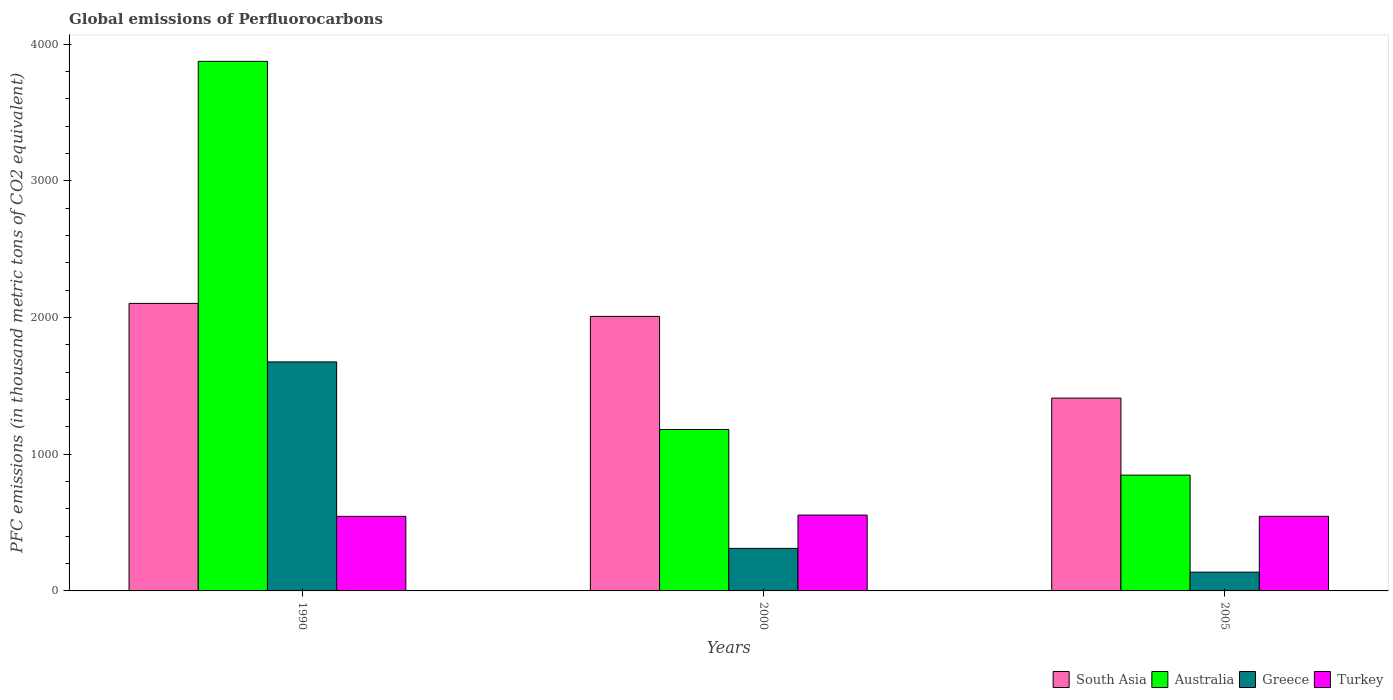What is the label of the 1st group of bars from the left?
Make the answer very short. 1990. In how many cases, is the number of bars for a given year not equal to the number of legend labels?
Your answer should be very brief. 0. What is the global emissions of Perfluorocarbons in Turkey in 2000?
Ensure brevity in your answer.  554.9. Across all years, what is the maximum global emissions of Perfluorocarbons in Greece?
Keep it short and to the point. 1675.9. Across all years, what is the minimum global emissions of Perfluorocarbons in Turkey?
Offer a very short reply. 545.6. In which year was the global emissions of Perfluorocarbons in Turkey minimum?
Give a very brief answer. 1990. What is the total global emissions of Perfluorocarbons in Greece in the graph?
Offer a terse response. 2124.7. What is the difference between the global emissions of Perfluorocarbons in Australia in 2000 and that in 2005?
Your response must be concise. 334. What is the difference between the global emissions of Perfluorocarbons in South Asia in 2000 and the global emissions of Perfluorocarbons in Turkey in 1990?
Give a very brief answer. 1463.2. What is the average global emissions of Perfluorocarbons in Turkey per year?
Your answer should be compact. 548.8. In the year 2005, what is the difference between the global emissions of Perfluorocarbons in South Asia and global emissions of Perfluorocarbons in Australia?
Make the answer very short. 563.44. In how many years, is the global emissions of Perfluorocarbons in Turkey greater than 1600 thousand metric tons?
Give a very brief answer. 0. What is the ratio of the global emissions of Perfluorocarbons in South Asia in 1990 to that in 2005?
Give a very brief answer. 1.49. What is the difference between the highest and the second highest global emissions of Perfluorocarbons in Australia?
Provide a short and direct response. 2693.8. What is the difference between the highest and the lowest global emissions of Perfluorocarbons in Greece?
Your answer should be very brief. 1538.4. Is it the case that in every year, the sum of the global emissions of Perfluorocarbons in Australia and global emissions of Perfluorocarbons in Turkey is greater than the sum of global emissions of Perfluorocarbons in South Asia and global emissions of Perfluorocarbons in Greece?
Offer a very short reply. No. Is it the case that in every year, the sum of the global emissions of Perfluorocarbons in Australia and global emissions of Perfluorocarbons in Greece is greater than the global emissions of Perfluorocarbons in South Asia?
Give a very brief answer. No. How many bars are there?
Keep it short and to the point. 12. Are all the bars in the graph horizontal?
Your answer should be compact. No. How many years are there in the graph?
Offer a very short reply. 3. What is the difference between two consecutive major ticks on the Y-axis?
Make the answer very short. 1000. Are the values on the major ticks of Y-axis written in scientific E-notation?
Provide a succinct answer. No. Does the graph contain any zero values?
Offer a terse response. No. Where does the legend appear in the graph?
Your answer should be very brief. Bottom right. How many legend labels are there?
Your answer should be compact. 4. How are the legend labels stacked?
Your answer should be compact. Horizontal. What is the title of the graph?
Provide a short and direct response. Global emissions of Perfluorocarbons. Does "Costa Rica" appear as one of the legend labels in the graph?
Provide a short and direct response. No. What is the label or title of the Y-axis?
Your response must be concise. PFC emissions (in thousand metric tons of CO2 equivalent). What is the PFC emissions (in thousand metric tons of CO2 equivalent) in South Asia in 1990?
Your response must be concise. 2104. What is the PFC emissions (in thousand metric tons of CO2 equivalent) in Australia in 1990?
Your answer should be compact. 3875.2. What is the PFC emissions (in thousand metric tons of CO2 equivalent) in Greece in 1990?
Your answer should be compact. 1675.9. What is the PFC emissions (in thousand metric tons of CO2 equivalent) of Turkey in 1990?
Offer a terse response. 545.6. What is the PFC emissions (in thousand metric tons of CO2 equivalent) in South Asia in 2000?
Make the answer very short. 2008.8. What is the PFC emissions (in thousand metric tons of CO2 equivalent) of Australia in 2000?
Keep it short and to the point. 1181.4. What is the PFC emissions (in thousand metric tons of CO2 equivalent) of Greece in 2000?
Your response must be concise. 311.3. What is the PFC emissions (in thousand metric tons of CO2 equivalent) in Turkey in 2000?
Give a very brief answer. 554.9. What is the PFC emissions (in thousand metric tons of CO2 equivalent) in South Asia in 2005?
Give a very brief answer. 1410.84. What is the PFC emissions (in thousand metric tons of CO2 equivalent) of Australia in 2005?
Your answer should be compact. 847.4. What is the PFC emissions (in thousand metric tons of CO2 equivalent) of Greece in 2005?
Offer a very short reply. 137.5. What is the PFC emissions (in thousand metric tons of CO2 equivalent) of Turkey in 2005?
Give a very brief answer. 545.9. Across all years, what is the maximum PFC emissions (in thousand metric tons of CO2 equivalent) of South Asia?
Offer a terse response. 2104. Across all years, what is the maximum PFC emissions (in thousand metric tons of CO2 equivalent) of Australia?
Provide a short and direct response. 3875.2. Across all years, what is the maximum PFC emissions (in thousand metric tons of CO2 equivalent) of Greece?
Provide a succinct answer. 1675.9. Across all years, what is the maximum PFC emissions (in thousand metric tons of CO2 equivalent) of Turkey?
Make the answer very short. 554.9. Across all years, what is the minimum PFC emissions (in thousand metric tons of CO2 equivalent) of South Asia?
Keep it short and to the point. 1410.84. Across all years, what is the minimum PFC emissions (in thousand metric tons of CO2 equivalent) in Australia?
Provide a short and direct response. 847.4. Across all years, what is the minimum PFC emissions (in thousand metric tons of CO2 equivalent) in Greece?
Your response must be concise. 137.5. Across all years, what is the minimum PFC emissions (in thousand metric tons of CO2 equivalent) in Turkey?
Make the answer very short. 545.6. What is the total PFC emissions (in thousand metric tons of CO2 equivalent) of South Asia in the graph?
Offer a terse response. 5523.64. What is the total PFC emissions (in thousand metric tons of CO2 equivalent) of Australia in the graph?
Give a very brief answer. 5904. What is the total PFC emissions (in thousand metric tons of CO2 equivalent) in Greece in the graph?
Your answer should be compact. 2124.7. What is the total PFC emissions (in thousand metric tons of CO2 equivalent) of Turkey in the graph?
Your answer should be compact. 1646.4. What is the difference between the PFC emissions (in thousand metric tons of CO2 equivalent) in South Asia in 1990 and that in 2000?
Offer a terse response. 95.2. What is the difference between the PFC emissions (in thousand metric tons of CO2 equivalent) in Australia in 1990 and that in 2000?
Your response must be concise. 2693.8. What is the difference between the PFC emissions (in thousand metric tons of CO2 equivalent) in Greece in 1990 and that in 2000?
Your answer should be very brief. 1364.6. What is the difference between the PFC emissions (in thousand metric tons of CO2 equivalent) in Turkey in 1990 and that in 2000?
Your answer should be compact. -9.3. What is the difference between the PFC emissions (in thousand metric tons of CO2 equivalent) of South Asia in 1990 and that in 2005?
Your response must be concise. 693.16. What is the difference between the PFC emissions (in thousand metric tons of CO2 equivalent) of Australia in 1990 and that in 2005?
Your answer should be very brief. 3027.8. What is the difference between the PFC emissions (in thousand metric tons of CO2 equivalent) in Greece in 1990 and that in 2005?
Provide a short and direct response. 1538.4. What is the difference between the PFC emissions (in thousand metric tons of CO2 equivalent) of South Asia in 2000 and that in 2005?
Provide a succinct answer. 597.96. What is the difference between the PFC emissions (in thousand metric tons of CO2 equivalent) of Australia in 2000 and that in 2005?
Provide a short and direct response. 334. What is the difference between the PFC emissions (in thousand metric tons of CO2 equivalent) of Greece in 2000 and that in 2005?
Ensure brevity in your answer.  173.8. What is the difference between the PFC emissions (in thousand metric tons of CO2 equivalent) in Turkey in 2000 and that in 2005?
Offer a terse response. 9. What is the difference between the PFC emissions (in thousand metric tons of CO2 equivalent) of South Asia in 1990 and the PFC emissions (in thousand metric tons of CO2 equivalent) of Australia in 2000?
Offer a very short reply. 922.6. What is the difference between the PFC emissions (in thousand metric tons of CO2 equivalent) of South Asia in 1990 and the PFC emissions (in thousand metric tons of CO2 equivalent) of Greece in 2000?
Your answer should be very brief. 1792.7. What is the difference between the PFC emissions (in thousand metric tons of CO2 equivalent) in South Asia in 1990 and the PFC emissions (in thousand metric tons of CO2 equivalent) in Turkey in 2000?
Ensure brevity in your answer.  1549.1. What is the difference between the PFC emissions (in thousand metric tons of CO2 equivalent) in Australia in 1990 and the PFC emissions (in thousand metric tons of CO2 equivalent) in Greece in 2000?
Your answer should be compact. 3563.9. What is the difference between the PFC emissions (in thousand metric tons of CO2 equivalent) in Australia in 1990 and the PFC emissions (in thousand metric tons of CO2 equivalent) in Turkey in 2000?
Offer a terse response. 3320.3. What is the difference between the PFC emissions (in thousand metric tons of CO2 equivalent) in Greece in 1990 and the PFC emissions (in thousand metric tons of CO2 equivalent) in Turkey in 2000?
Ensure brevity in your answer.  1121. What is the difference between the PFC emissions (in thousand metric tons of CO2 equivalent) of South Asia in 1990 and the PFC emissions (in thousand metric tons of CO2 equivalent) of Australia in 2005?
Your answer should be very brief. 1256.6. What is the difference between the PFC emissions (in thousand metric tons of CO2 equivalent) in South Asia in 1990 and the PFC emissions (in thousand metric tons of CO2 equivalent) in Greece in 2005?
Offer a terse response. 1966.5. What is the difference between the PFC emissions (in thousand metric tons of CO2 equivalent) of South Asia in 1990 and the PFC emissions (in thousand metric tons of CO2 equivalent) of Turkey in 2005?
Provide a short and direct response. 1558.1. What is the difference between the PFC emissions (in thousand metric tons of CO2 equivalent) of Australia in 1990 and the PFC emissions (in thousand metric tons of CO2 equivalent) of Greece in 2005?
Ensure brevity in your answer.  3737.7. What is the difference between the PFC emissions (in thousand metric tons of CO2 equivalent) of Australia in 1990 and the PFC emissions (in thousand metric tons of CO2 equivalent) of Turkey in 2005?
Offer a terse response. 3329.3. What is the difference between the PFC emissions (in thousand metric tons of CO2 equivalent) of Greece in 1990 and the PFC emissions (in thousand metric tons of CO2 equivalent) of Turkey in 2005?
Keep it short and to the point. 1130. What is the difference between the PFC emissions (in thousand metric tons of CO2 equivalent) of South Asia in 2000 and the PFC emissions (in thousand metric tons of CO2 equivalent) of Australia in 2005?
Offer a terse response. 1161.4. What is the difference between the PFC emissions (in thousand metric tons of CO2 equivalent) of South Asia in 2000 and the PFC emissions (in thousand metric tons of CO2 equivalent) of Greece in 2005?
Give a very brief answer. 1871.3. What is the difference between the PFC emissions (in thousand metric tons of CO2 equivalent) of South Asia in 2000 and the PFC emissions (in thousand metric tons of CO2 equivalent) of Turkey in 2005?
Offer a very short reply. 1462.9. What is the difference between the PFC emissions (in thousand metric tons of CO2 equivalent) of Australia in 2000 and the PFC emissions (in thousand metric tons of CO2 equivalent) of Greece in 2005?
Make the answer very short. 1043.9. What is the difference between the PFC emissions (in thousand metric tons of CO2 equivalent) in Australia in 2000 and the PFC emissions (in thousand metric tons of CO2 equivalent) in Turkey in 2005?
Provide a short and direct response. 635.5. What is the difference between the PFC emissions (in thousand metric tons of CO2 equivalent) of Greece in 2000 and the PFC emissions (in thousand metric tons of CO2 equivalent) of Turkey in 2005?
Provide a short and direct response. -234.6. What is the average PFC emissions (in thousand metric tons of CO2 equivalent) in South Asia per year?
Ensure brevity in your answer.  1841.21. What is the average PFC emissions (in thousand metric tons of CO2 equivalent) in Australia per year?
Give a very brief answer. 1968. What is the average PFC emissions (in thousand metric tons of CO2 equivalent) of Greece per year?
Offer a very short reply. 708.23. What is the average PFC emissions (in thousand metric tons of CO2 equivalent) in Turkey per year?
Offer a very short reply. 548.8. In the year 1990, what is the difference between the PFC emissions (in thousand metric tons of CO2 equivalent) in South Asia and PFC emissions (in thousand metric tons of CO2 equivalent) in Australia?
Provide a succinct answer. -1771.2. In the year 1990, what is the difference between the PFC emissions (in thousand metric tons of CO2 equivalent) in South Asia and PFC emissions (in thousand metric tons of CO2 equivalent) in Greece?
Make the answer very short. 428.1. In the year 1990, what is the difference between the PFC emissions (in thousand metric tons of CO2 equivalent) of South Asia and PFC emissions (in thousand metric tons of CO2 equivalent) of Turkey?
Your response must be concise. 1558.4. In the year 1990, what is the difference between the PFC emissions (in thousand metric tons of CO2 equivalent) in Australia and PFC emissions (in thousand metric tons of CO2 equivalent) in Greece?
Your response must be concise. 2199.3. In the year 1990, what is the difference between the PFC emissions (in thousand metric tons of CO2 equivalent) of Australia and PFC emissions (in thousand metric tons of CO2 equivalent) of Turkey?
Offer a terse response. 3329.6. In the year 1990, what is the difference between the PFC emissions (in thousand metric tons of CO2 equivalent) in Greece and PFC emissions (in thousand metric tons of CO2 equivalent) in Turkey?
Provide a succinct answer. 1130.3. In the year 2000, what is the difference between the PFC emissions (in thousand metric tons of CO2 equivalent) of South Asia and PFC emissions (in thousand metric tons of CO2 equivalent) of Australia?
Provide a succinct answer. 827.4. In the year 2000, what is the difference between the PFC emissions (in thousand metric tons of CO2 equivalent) in South Asia and PFC emissions (in thousand metric tons of CO2 equivalent) in Greece?
Your response must be concise. 1697.5. In the year 2000, what is the difference between the PFC emissions (in thousand metric tons of CO2 equivalent) of South Asia and PFC emissions (in thousand metric tons of CO2 equivalent) of Turkey?
Your answer should be compact. 1453.9. In the year 2000, what is the difference between the PFC emissions (in thousand metric tons of CO2 equivalent) of Australia and PFC emissions (in thousand metric tons of CO2 equivalent) of Greece?
Provide a short and direct response. 870.1. In the year 2000, what is the difference between the PFC emissions (in thousand metric tons of CO2 equivalent) in Australia and PFC emissions (in thousand metric tons of CO2 equivalent) in Turkey?
Your answer should be compact. 626.5. In the year 2000, what is the difference between the PFC emissions (in thousand metric tons of CO2 equivalent) in Greece and PFC emissions (in thousand metric tons of CO2 equivalent) in Turkey?
Keep it short and to the point. -243.6. In the year 2005, what is the difference between the PFC emissions (in thousand metric tons of CO2 equivalent) of South Asia and PFC emissions (in thousand metric tons of CO2 equivalent) of Australia?
Provide a succinct answer. 563.44. In the year 2005, what is the difference between the PFC emissions (in thousand metric tons of CO2 equivalent) of South Asia and PFC emissions (in thousand metric tons of CO2 equivalent) of Greece?
Ensure brevity in your answer.  1273.34. In the year 2005, what is the difference between the PFC emissions (in thousand metric tons of CO2 equivalent) in South Asia and PFC emissions (in thousand metric tons of CO2 equivalent) in Turkey?
Keep it short and to the point. 864.94. In the year 2005, what is the difference between the PFC emissions (in thousand metric tons of CO2 equivalent) in Australia and PFC emissions (in thousand metric tons of CO2 equivalent) in Greece?
Your response must be concise. 709.9. In the year 2005, what is the difference between the PFC emissions (in thousand metric tons of CO2 equivalent) in Australia and PFC emissions (in thousand metric tons of CO2 equivalent) in Turkey?
Ensure brevity in your answer.  301.5. In the year 2005, what is the difference between the PFC emissions (in thousand metric tons of CO2 equivalent) in Greece and PFC emissions (in thousand metric tons of CO2 equivalent) in Turkey?
Your response must be concise. -408.4. What is the ratio of the PFC emissions (in thousand metric tons of CO2 equivalent) in South Asia in 1990 to that in 2000?
Offer a very short reply. 1.05. What is the ratio of the PFC emissions (in thousand metric tons of CO2 equivalent) in Australia in 1990 to that in 2000?
Provide a succinct answer. 3.28. What is the ratio of the PFC emissions (in thousand metric tons of CO2 equivalent) of Greece in 1990 to that in 2000?
Provide a short and direct response. 5.38. What is the ratio of the PFC emissions (in thousand metric tons of CO2 equivalent) of Turkey in 1990 to that in 2000?
Your answer should be compact. 0.98. What is the ratio of the PFC emissions (in thousand metric tons of CO2 equivalent) in South Asia in 1990 to that in 2005?
Provide a short and direct response. 1.49. What is the ratio of the PFC emissions (in thousand metric tons of CO2 equivalent) in Australia in 1990 to that in 2005?
Make the answer very short. 4.57. What is the ratio of the PFC emissions (in thousand metric tons of CO2 equivalent) in Greece in 1990 to that in 2005?
Offer a very short reply. 12.19. What is the ratio of the PFC emissions (in thousand metric tons of CO2 equivalent) of South Asia in 2000 to that in 2005?
Your answer should be compact. 1.42. What is the ratio of the PFC emissions (in thousand metric tons of CO2 equivalent) of Australia in 2000 to that in 2005?
Keep it short and to the point. 1.39. What is the ratio of the PFC emissions (in thousand metric tons of CO2 equivalent) of Greece in 2000 to that in 2005?
Your response must be concise. 2.26. What is the ratio of the PFC emissions (in thousand metric tons of CO2 equivalent) of Turkey in 2000 to that in 2005?
Keep it short and to the point. 1.02. What is the difference between the highest and the second highest PFC emissions (in thousand metric tons of CO2 equivalent) of South Asia?
Offer a very short reply. 95.2. What is the difference between the highest and the second highest PFC emissions (in thousand metric tons of CO2 equivalent) in Australia?
Your answer should be very brief. 2693.8. What is the difference between the highest and the second highest PFC emissions (in thousand metric tons of CO2 equivalent) in Greece?
Your response must be concise. 1364.6. What is the difference between the highest and the lowest PFC emissions (in thousand metric tons of CO2 equivalent) of South Asia?
Give a very brief answer. 693.16. What is the difference between the highest and the lowest PFC emissions (in thousand metric tons of CO2 equivalent) in Australia?
Keep it short and to the point. 3027.8. What is the difference between the highest and the lowest PFC emissions (in thousand metric tons of CO2 equivalent) in Greece?
Your response must be concise. 1538.4. 